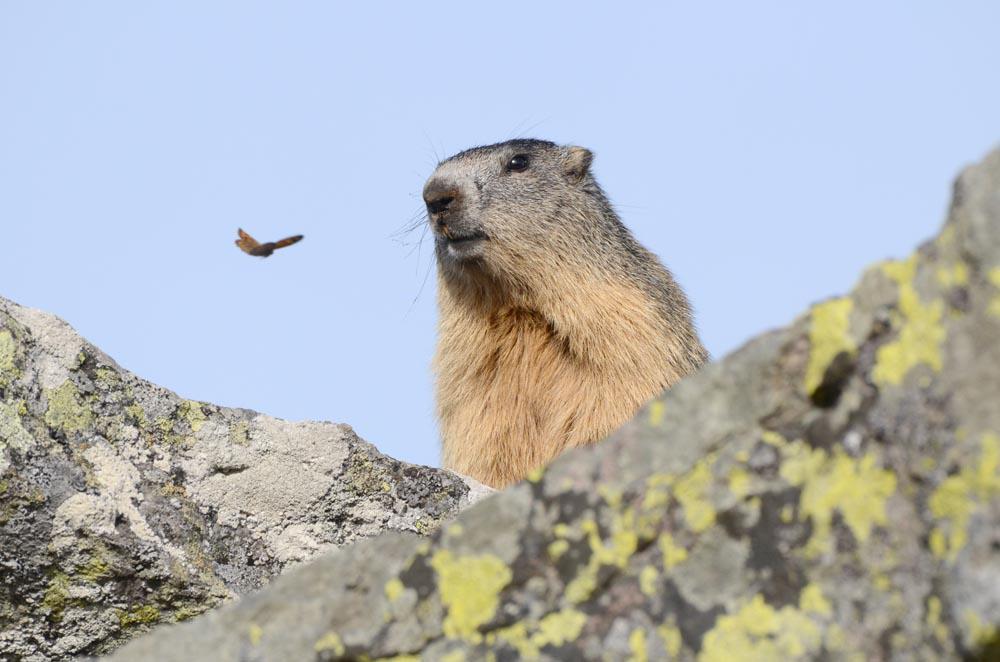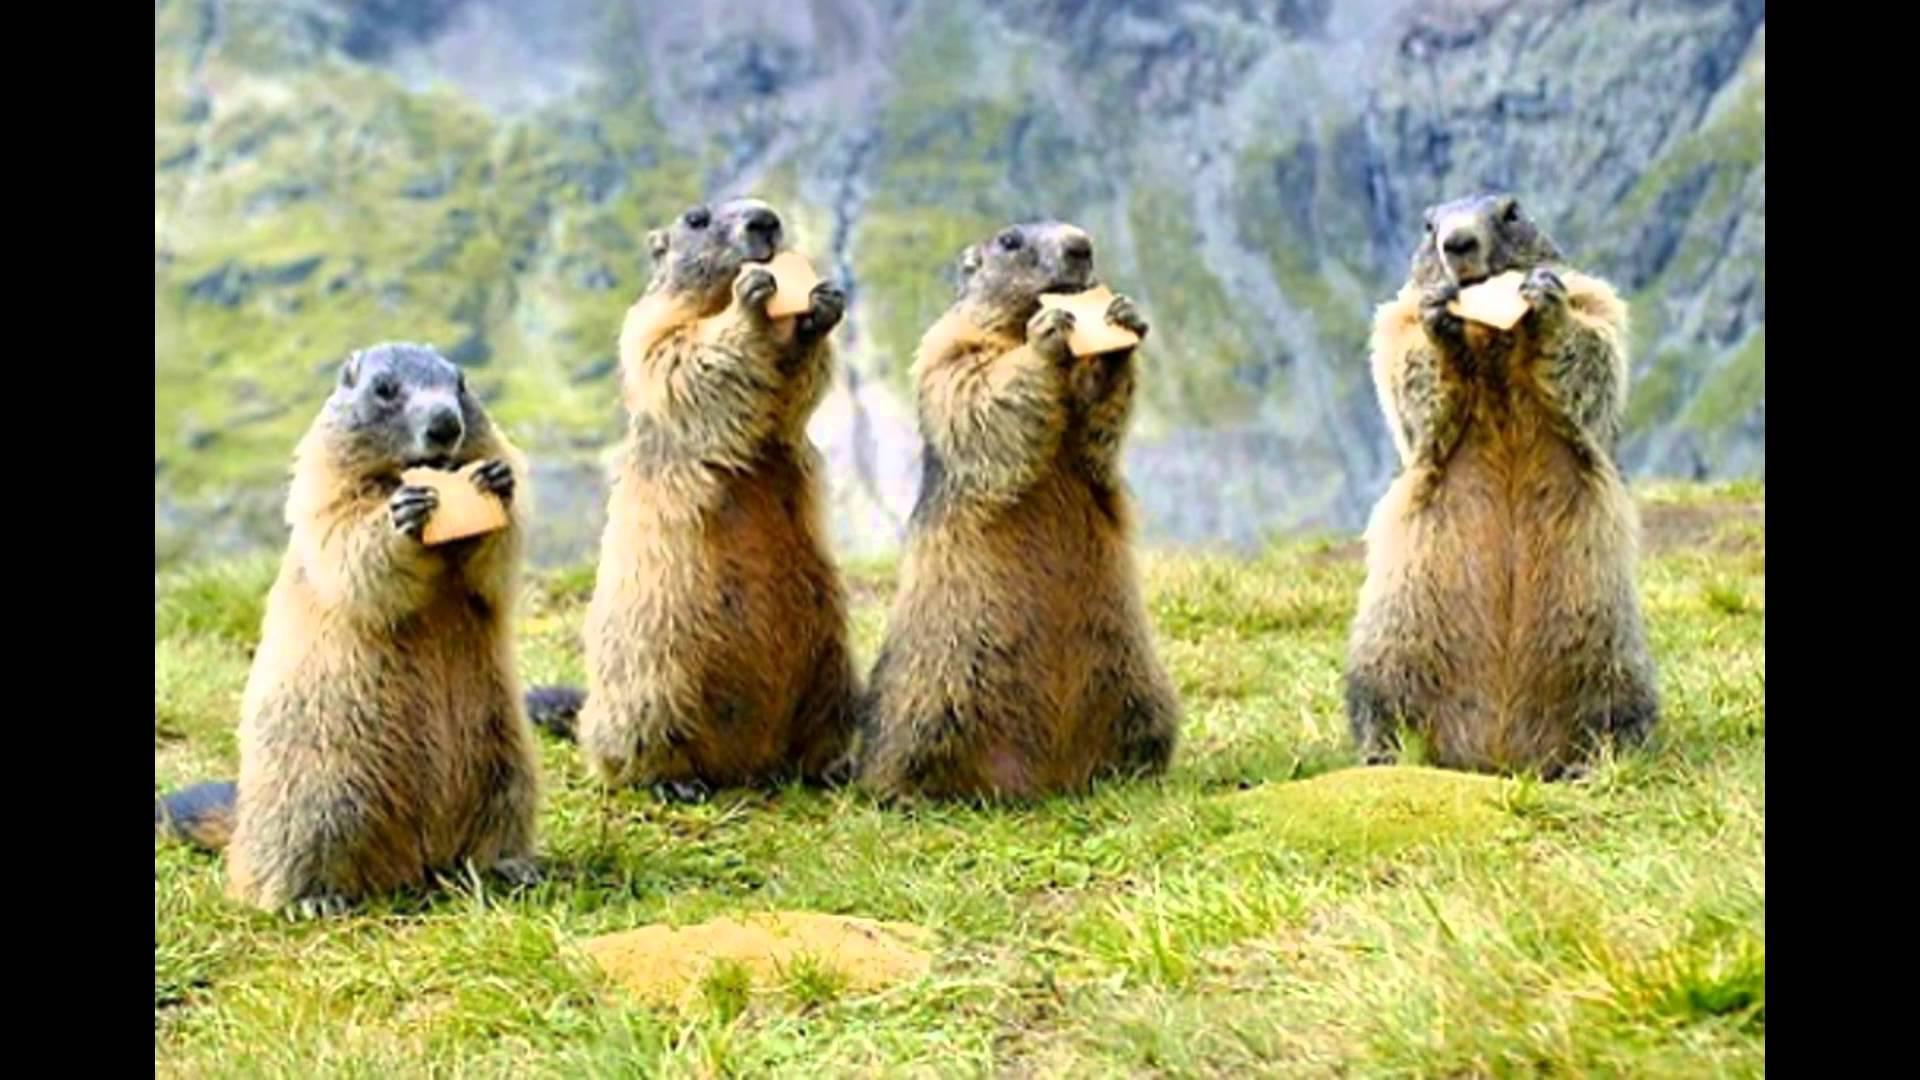The first image is the image on the left, the second image is the image on the right. Examine the images to the left and right. Is the description "In the right image there are two rodents facing towards the right." accurate? Answer yes or no. No. The first image is the image on the left, the second image is the image on the right. Assess this claim about the two images: "There are two marmots in the right image, and three on the left". Correct or not? Answer yes or no. No. 